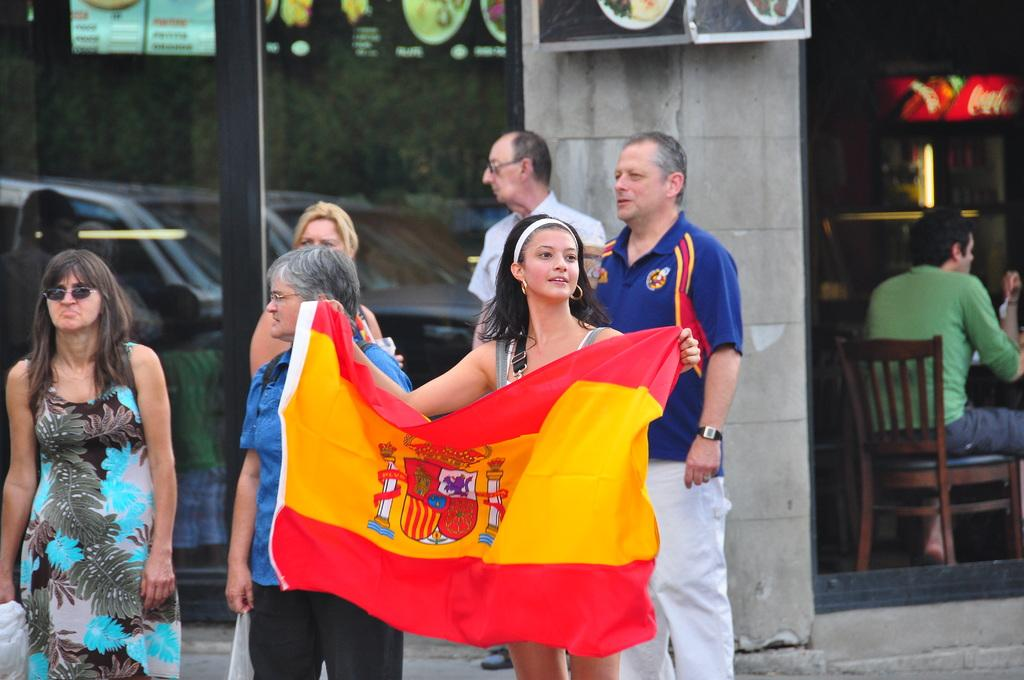What are the people in the image doing? The people in the image are standing. What is the woman holding in the image? The woman is holding a flag. Can you describe the person in the background? There is a person sitting on a chair in the background. What else can be seen in the image besides people? There are vehicles visible in the image. What scientific experiment is being conducted with the pigs in the image? There are no pigs present in the image, and therefore no scientific experiment involving pigs can be observed. 